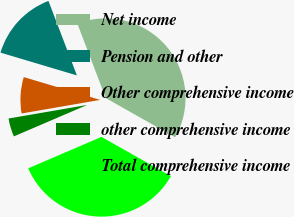<chart> <loc_0><loc_0><loc_500><loc_500><pie_chart><fcel>Net income<fcel>Pension and other<fcel>Other comprehensive income<fcel>other comprehensive income<fcel>Total comprehensive income<nl><fcel>38.99%<fcel>14.58%<fcel>7.34%<fcel>3.73%<fcel>35.37%<nl></chart> 